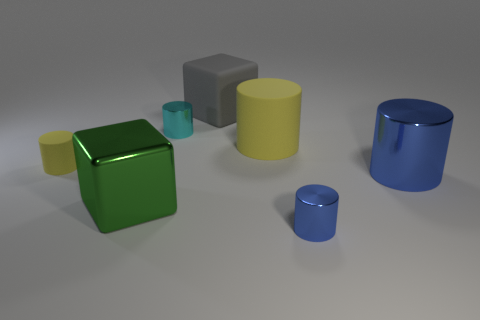What material is the tiny cyan object?
Make the answer very short. Metal. How many other objects are there of the same material as the gray cube?
Ensure brevity in your answer.  2. What number of blue balls are there?
Keep it short and to the point. 0. There is a green thing that is the same shape as the gray rubber thing; what is its material?
Your response must be concise. Metal. Do the thing in front of the big metallic cube and the tiny cyan object have the same material?
Your answer should be very brief. Yes. Are there more green blocks to the right of the big blue cylinder than yellow rubber cylinders on the left side of the gray rubber cube?
Your answer should be compact. No. The gray matte object is what size?
Your response must be concise. Large. There is a green object that is made of the same material as the cyan cylinder; what shape is it?
Your response must be concise. Cube. There is a big thing that is right of the small blue metallic object; is it the same shape as the big yellow matte object?
Your answer should be compact. Yes. What number of things are either matte cylinders or big gray rubber objects?
Provide a succinct answer. 3. 